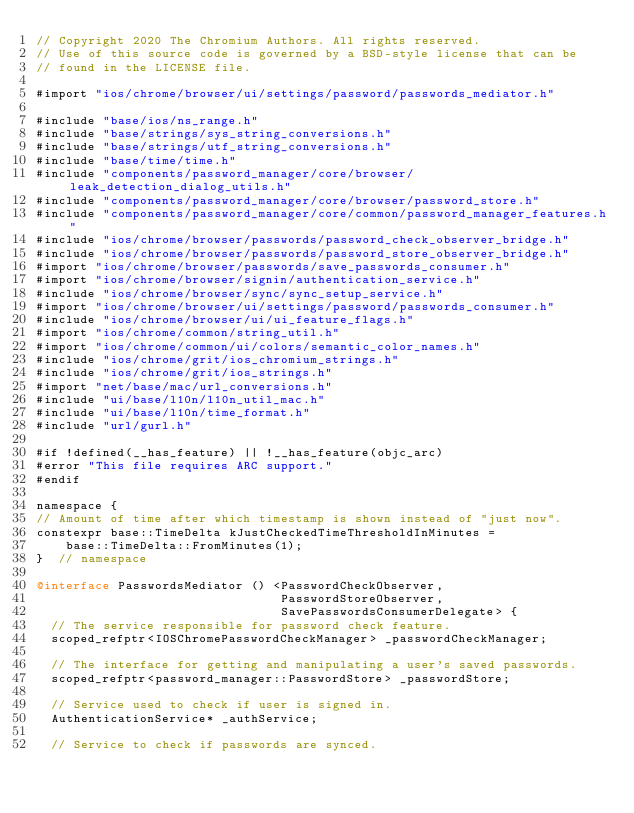Convert code to text. <code><loc_0><loc_0><loc_500><loc_500><_ObjectiveC_>// Copyright 2020 The Chromium Authors. All rights reserved.
// Use of this source code is governed by a BSD-style license that can be
// found in the LICENSE file.

#import "ios/chrome/browser/ui/settings/password/passwords_mediator.h"

#include "base/ios/ns_range.h"
#include "base/strings/sys_string_conversions.h"
#include "base/strings/utf_string_conversions.h"
#include "base/time/time.h"
#include "components/password_manager/core/browser/leak_detection_dialog_utils.h"
#include "components/password_manager/core/browser/password_store.h"
#include "components/password_manager/core/common/password_manager_features.h"
#include "ios/chrome/browser/passwords/password_check_observer_bridge.h"
#include "ios/chrome/browser/passwords/password_store_observer_bridge.h"
#import "ios/chrome/browser/passwords/save_passwords_consumer.h"
#import "ios/chrome/browser/signin/authentication_service.h"
#include "ios/chrome/browser/sync/sync_setup_service.h"
#import "ios/chrome/browser/ui/settings/password/passwords_consumer.h"
#include "ios/chrome/browser/ui/ui_feature_flags.h"
#import "ios/chrome/common/string_util.h"
#import "ios/chrome/common/ui/colors/semantic_color_names.h"
#include "ios/chrome/grit/ios_chromium_strings.h"
#include "ios/chrome/grit/ios_strings.h"
#import "net/base/mac/url_conversions.h"
#include "ui/base/l10n/l10n_util_mac.h"
#include "ui/base/l10n/time_format.h"
#include "url/gurl.h"

#if !defined(__has_feature) || !__has_feature(objc_arc)
#error "This file requires ARC support."
#endif

namespace {
// Amount of time after which timestamp is shown instead of "just now".
constexpr base::TimeDelta kJustCheckedTimeThresholdInMinutes =
    base::TimeDelta::FromMinutes(1);
}  // namespace

@interface PasswordsMediator () <PasswordCheckObserver,
                                 PasswordStoreObserver,
                                 SavePasswordsConsumerDelegate> {
  // The service responsible for password check feature.
  scoped_refptr<IOSChromePasswordCheckManager> _passwordCheckManager;

  // The interface for getting and manipulating a user's saved passwords.
  scoped_refptr<password_manager::PasswordStore> _passwordStore;

  // Service used to check if user is signed in.
  AuthenticationService* _authService;

  // Service to check if passwords are synced.</code> 